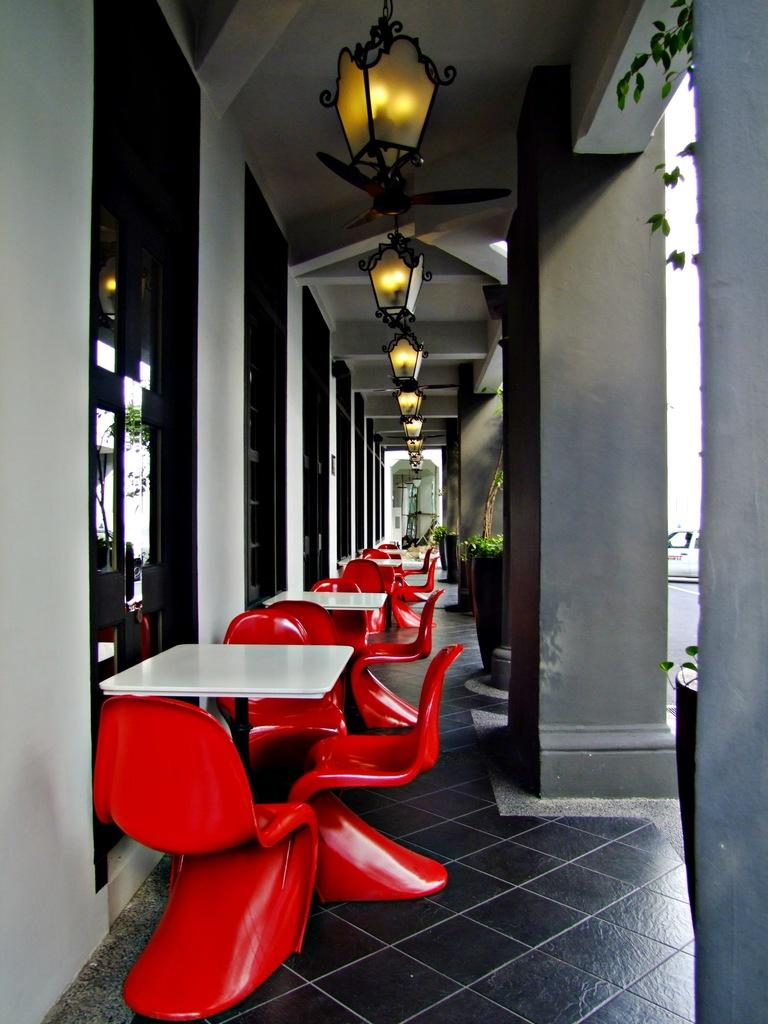What type of furniture can be seen in the image? There are tables in the image. How are the chairs arranged in the image? The chairs are arranged in a line in the image. What type of material is used for the windows in the image? The windows in the image are made of glass. Where are the glass windows attached in the image? The glass windows are attached to a wall in the image. What can be seen on the roof in the image? There are lights on the roof in the image. What type of whip is being used to prepare the meat on the sidewalk in the image? There is no whip, meat, or sidewalk present in the image. 